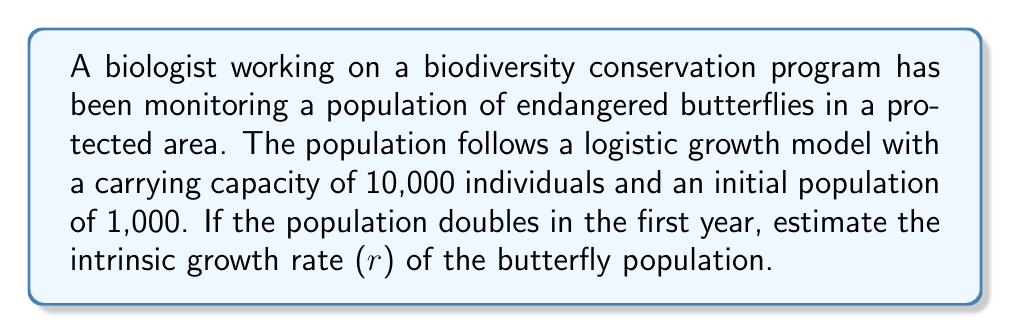Show me your answer to this math problem. To solve this problem, we'll use the logistic growth model and follow these steps:

1) The logistic growth model is given by the equation:

   $$N(t) = \frac{K}{1 + (\frac{K}{N_0} - 1)e^{-rt}}$$

   Where:
   $N(t)$ is the population at time $t$
   $K$ is the carrying capacity
   $N_0$ is the initial population
   $r$ is the intrinsic growth rate
   $t$ is time

2) We're given:
   $K = 10,000$
   $N_0 = 1,000$
   $N(1) = 2,000$ (population doubles in the first year)
   $t = 1$

3) Substituting these values into the equation:

   $$2000 = \frac{10000}{1 + (\frac{10000}{1000} - 1)e^{-r(1)}}$$

4) Simplify:

   $$2000 = \frac{10000}{1 + 9e^{-r}}$$

5) Multiply both sides by $(1 + 9e^{-r})$:

   $$2000(1 + 9e^{-r}) = 10000$$

6) Expand:

   $$2000 + 18000e^{-r} = 10000$$

7) Subtract 2000 from both sides:

   $$18000e^{-r} = 8000$$

8) Divide both sides by 18000:

   $$e^{-r} = \frac{4}{9}$$

9) Take the natural log of both sides:

   $$-r = \ln(\frac{4}{9})$$

10) Solve for r:

    $$r = -\ln(\frac{4}{9}) = \ln(\frac{9}{4}) \approx 0.8109$$
Answer: $r \approx 0.8109$ 